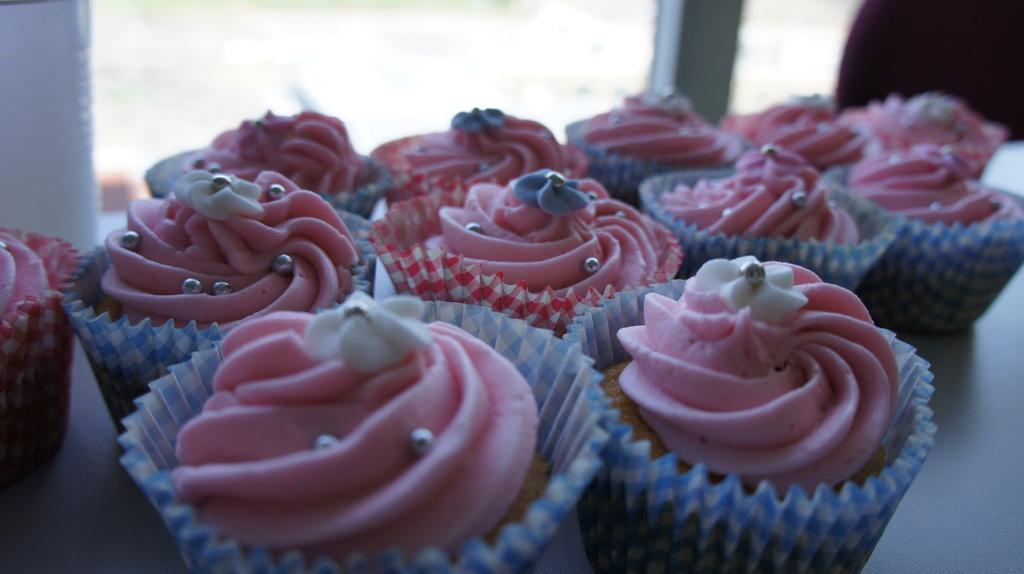What type of food can be seen in the image? There are cupcakes in the image. Where are the cupcakes located? The cupcakes are placed on a table. What can be seen in the background of the image? There is a window visible in the background of the image. What form does the back of the cupcakes take in the image? The cupcakes do not have a back, as they are round and have no distinct front or back. 